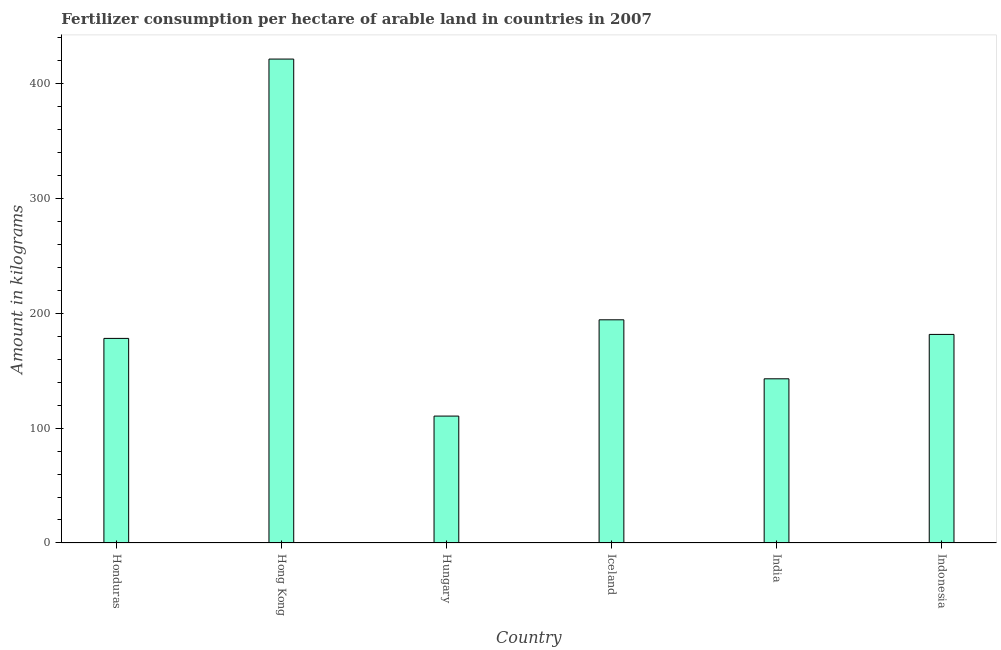What is the title of the graph?
Offer a terse response. Fertilizer consumption per hectare of arable land in countries in 2007 . What is the label or title of the X-axis?
Your response must be concise. Country. What is the label or title of the Y-axis?
Keep it short and to the point. Amount in kilograms. What is the amount of fertilizer consumption in Honduras?
Give a very brief answer. 178. Across all countries, what is the maximum amount of fertilizer consumption?
Your answer should be very brief. 421. Across all countries, what is the minimum amount of fertilizer consumption?
Your answer should be compact. 110.41. In which country was the amount of fertilizer consumption maximum?
Ensure brevity in your answer.  Hong Kong. In which country was the amount of fertilizer consumption minimum?
Provide a succinct answer. Hungary. What is the sum of the amount of fertilizer consumption?
Give a very brief answer. 1227.87. What is the difference between the amount of fertilizer consumption in India and Indonesia?
Make the answer very short. -38.62. What is the average amount of fertilizer consumption per country?
Give a very brief answer. 204.64. What is the median amount of fertilizer consumption?
Provide a succinct answer. 179.73. In how many countries, is the amount of fertilizer consumption greater than 60 kg?
Offer a very short reply. 6. What is the ratio of the amount of fertilizer consumption in Hong Kong to that in India?
Provide a short and direct response. 2.95. What is the difference between the highest and the second highest amount of fertilizer consumption?
Ensure brevity in your answer.  226.83. Is the sum of the amount of fertilizer consumption in Honduras and Hungary greater than the maximum amount of fertilizer consumption across all countries?
Keep it short and to the point. No. What is the difference between the highest and the lowest amount of fertilizer consumption?
Offer a very short reply. 310.59. How many bars are there?
Provide a succinct answer. 6. Are the values on the major ticks of Y-axis written in scientific E-notation?
Provide a succinct answer. No. What is the Amount in kilograms in Honduras?
Provide a succinct answer. 178. What is the Amount in kilograms of Hong Kong?
Offer a terse response. 421. What is the Amount in kilograms in Hungary?
Offer a terse response. 110.41. What is the Amount in kilograms of Iceland?
Give a very brief answer. 194.17. What is the Amount in kilograms in India?
Offer a very short reply. 142.84. What is the Amount in kilograms in Indonesia?
Provide a short and direct response. 181.46. What is the difference between the Amount in kilograms in Honduras and Hong Kong?
Keep it short and to the point. -243. What is the difference between the Amount in kilograms in Honduras and Hungary?
Your answer should be compact. 67.59. What is the difference between the Amount in kilograms in Honduras and Iceland?
Your answer should be very brief. -16.17. What is the difference between the Amount in kilograms in Honduras and India?
Offer a terse response. 35.16. What is the difference between the Amount in kilograms in Honduras and Indonesia?
Offer a terse response. -3.46. What is the difference between the Amount in kilograms in Hong Kong and Hungary?
Your answer should be very brief. 310.59. What is the difference between the Amount in kilograms in Hong Kong and Iceland?
Offer a terse response. 226.83. What is the difference between the Amount in kilograms in Hong Kong and India?
Offer a very short reply. 278.16. What is the difference between the Amount in kilograms in Hong Kong and Indonesia?
Ensure brevity in your answer.  239.54. What is the difference between the Amount in kilograms in Hungary and Iceland?
Offer a very short reply. -83.76. What is the difference between the Amount in kilograms in Hungary and India?
Offer a terse response. -32.43. What is the difference between the Amount in kilograms in Hungary and Indonesia?
Offer a terse response. -71.05. What is the difference between the Amount in kilograms in Iceland and India?
Provide a succinct answer. 51.33. What is the difference between the Amount in kilograms in Iceland and Indonesia?
Your response must be concise. 12.71. What is the difference between the Amount in kilograms in India and Indonesia?
Keep it short and to the point. -38.62. What is the ratio of the Amount in kilograms in Honduras to that in Hong Kong?
Your answer should be very brief. 0.42. What is the ratio of the Amount in kilograms in Honduras to that in Hungary?
Your response must be concise. 1.61. What is the ratio of the Amount in kilograms in Honduras to that in Iceland?
Provide a short and direct response. 0.92. What is the ratio of the Amount in kilograms in Honduras to that in India?
Provide a succinct answer. 1.25. What is the ratio of the Amount in kilograms in Hong Kong to that in Hungary?
Keep it short and to the point. 3.81. What is the ratio of the Amount in kilograms in Hong Kong to that in Iceland?
Provide a short and direct response. 2.17. What is the ratio of the Amount in kilograms in Hong Kong to that in India?
Your answer should be very brief. 2.95. What is the ratio of the Amount in kilograms in Hong Kong to that in Indonesia?
Provide a succinct answer. 2.32. What is the ratio of the Amount in kilograms in Hungary to that in Iceland?
Give a very brief answer. 0.57. What is the ratio of the Amount in kilograms in Hungary to that in India?
Your answer should be compact. 0.77. What is the ratio of the Amount in kilograms in Hungary to that in Indonesia?
Keep it short and to the point. 0.61. What is the ratio of the Amount in kilograms in Iceland to that in India?
Offer a very short reply. 1.36. What is the ratio of the Amount in kilograms in Iceland to that in Indonesia?
Offer a terse response. 1.07. What is the ratio of the Amount in kilograms in India to that in Indonesia?
Your response must be concise. 0.79. 